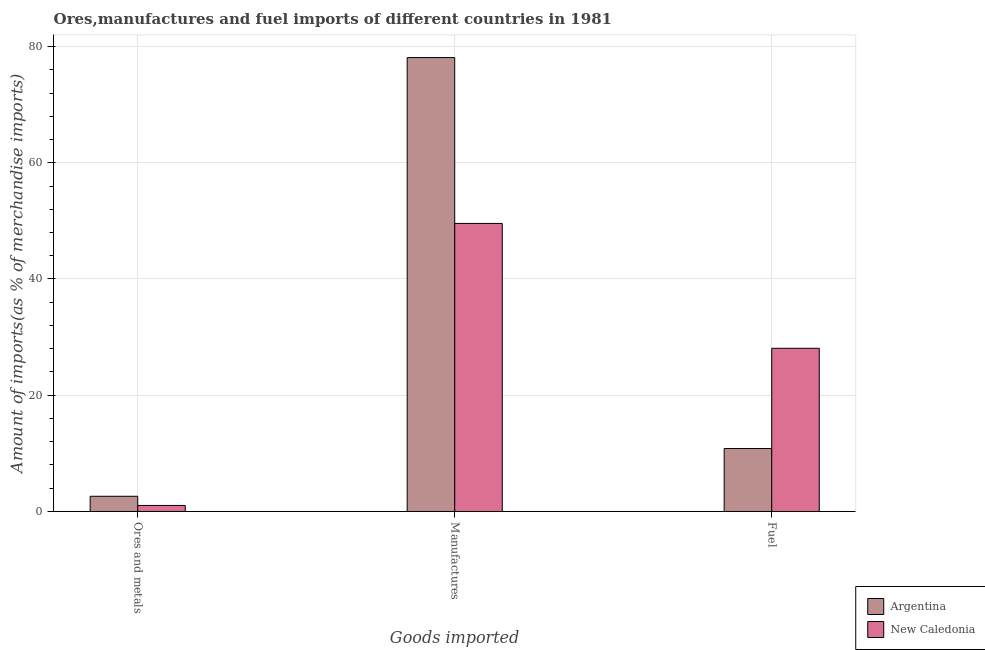How many groups of bars are there?
Offer a terse response. 3. Are the number of bars on each tick of the X-axis equal?
Ensure brevity in your answer.  Yes. What is the label of the 1st group of bars from the left?
Your response must be concise. Ores and metals. What is the percentage of fuel imports in Argentina?
Your answer should be compact. 10.83. Across all countries, what is the maximum percentage of manufactures imports?
Offer a terse response. 78.1. Across all countries, what is the minimum percentage of ores and metals imports?
Provide a short and direct response. 1.04. In which country was the percentage of ores and metals imports maximum?
Keep it short and to the point. Argentina. What is the total percentage of ores and metals imports in the graph?
Provide a short and direct response. 3.66. What is the difference between the percentage of fuel imports in Argentina and that in New Caledonia?
Offer a very short reply. -17.24. What is the difference between the percentage of fuel imports in Argentina and the percentage of ores and metals imports in New Caledonia?
Offer a terse response. 9.79. What is the average percentage of fuel imports per country?
Keep it short and to the point. 19.46. What is the difference between the percentage of ores and metals imports and percentage of fuel imports in New Caledonia?
Offer a very short reply. -27.04. What is the ratio of the percentage of manufactures imports in New Caledonia to that in Argentina?
Keep it short and to the point. 0.63. What is the difference between the highest and the second highest percentage of ores and metals imports?
Make the answer very short. 1.58. What is the difference between the highest and the lowest percentage of fuel imports?
Provide a succinct answer. 17.24. In how many countries, is the percentage of fuel imports greater than the average percentage of fuel imports taken over all countries?
Offer a very short reply. 1. Is the sum of the percentage of fuel imports in New Caledonia and Argentina greater than the maximum percentage of ores and metals imports across all countries?
Your answer should be compact. Yes. What does the 2nd bar from the left in Manufactures represents?
Offer a very short reply. New Caledonia. What does the 1st bar from the right in Ores and metals represents?
Keep it short and to the point. New Caledonia. How many bars are there?
Make the answer very short. 6. Are all the bars in the graph horizontal?
Offer a very short reply. No. Does the graph contain grids?
Your response must be concise. Yes. How are the legend labels stacked?
Offer a very short reply. Vertical. What is the title of the graph?
Give a very brief answer. Ores,manufactures and fuel imports of different countries in 1981. Does "Iran" appear as one of the legend labels in the graph?
Give a very brief answer. No. What is the label or title of the X-axis?
Ensure brevity in your answer.  Goods imported. What is the label or title of the Y-axis?
Provide a short and direct response. Amount of imports(as % of merchandise imports). What is the Amount of imports(as % of merchandise imports) in Argentina in Ores and metals?
Offer a terse response. 2.62. What is the Amount of imports(as % of merchandise imports) of New Caledonia in Ores and metals?
Ensure brevity in your answer.  1.04. What is the Amount of imports(as % of merchandise imports) in Argentina in Manufactures?
Make the answer very short. 78.1. What is the Amount of imports(as % of merchandise imports) of New Caledonia in Manufactures?
Provide a short and direct response. 49.56. What is the Amount of imports(as % of merchandise imports) in Argentina in Fuel?
Make the answer very short. 10.83. What is the Amount of imports(as % of merchandise imports) of New Caledonia in Fuel?
Make the answer very short. 28.08. Across all Goods imported, what is the maximum Amount of imports(as % of merchandise imports) of Argentina?
Your response must be concise. 78.1. Across all Goods imported, what is the maximum Amount of imports(as % of merchandise imports) in New Caledonia?
Your answer should be compact. 49.56. Across all Goods imported, what is the minimum Amount of imports(as % of merchandise imports) of Argentina?
Ensure brevity in your answer.  2.62. Across all Goods imported, what is the minimum Amount of imports(as % of merchandise imports) in New Caledonia?
Your response must be concise. 1.04. What is the total Amount of imports(as % of merchandise imports) of Argentina in the graph?
Offer a terse response. 91.55. What is the total Amount of imports(as % of merchandise imports) in New Caledonia in the graph?
Make the answer very short. 78.68. What is the difference between the Amount of imports(as % of merchandise imports) of Argentina in Ores and metals and that in Manufactures?
Offer a very short reply. -75.48. What is the difference between the Amount of imports(as % of merchandise imports) in New Caledonia in Ores and metals and that in Manufactures?
Your response must be concise. -48.52. What is the difference between the Amount of imports(as % of merchandise imports) in Argentina in Ores and metals and that in Fuel?
Keep it short and to the point. -8.22. What is the difference between the Amount of imports(as % of merchandise imports) in New Caledonia in Ores and metals and that in Fuel?
Keep it short and to the point. -27.04. What is the difference between the Amount of imports(as % of merchandise imports) of Argentina in Manufactures and that in Fuel?
Ensure brevity in your answer.  67.26. What is the difference between the Amount of imports(as % of merchandise imports) of New Caledonia in Manufactures and that in Fuel?
Make the answer very short. 21.49. What is the difference between the Amount of imports(as % of merchandise imports) in Argentina in Ores and metals and the Amount of imports(as % of merchandise imports) in New Caledonia in Manufactures?
Ensure brevity in your answer.  -46.95. What is the difference between the Amount of imports(as % of merchandise imports) in Argentina in Ores and metals and the Amount of imports(as % of merchandise imports) in New Caledonia in Fuel?
Provide a succinct answer. -25.46. What is the difference between the Amount of imports(as % of merchandise imports) in Argentina in Manufactures and the Amount of imports(as % of merchandise imports) in New Caledonia in Fuel?
Ensure brevity in your answer.  50.02. What is the average Amount of imports(as % of merchandise imports) of Argentina per Goods imported?
Provide a succinct answer. 30.52. What is the average Amount of imports(as % of merchandise imports) in New Caledonia per Goods imported?
Offer a terse response. 26.23. What is the difference between the Amount of imports(as % of merchandise imports) in Argentina and Amount of imports(as % of merchandise imports) in New Caledonia in Ores and metals?
Give a very brief answer. 1.58. What is the difference between the Amount of imports(as % of merchandise imports) in Argentina and Amount of imports(as % of merchandise imports) in New Caledonia in Manufactures?
Provide a succinct answer. 28.54. What is the difference between the Amount of imports(as % of merchandise imports) of Argentina and Amount of imports(as % of merchandise imports) of New Caledonia in Fuel?
Offer a very short reply. -17.24. What is the ratio of the Amount of imports(as % of merchandise imports) of Argentina in Ores and metals to that in Manufactures?
Keep it short and to the point. 0.03. What is the ratio of the Amount of imports(as % of merchandise imports) of New Caledonia in Ores and metals to that in Manufactures?
Offer a terse response. 0.02. What is the ratio of the Amount of imports(as % of merchandise imports) in Argentina in Ores and metals to that in Fuel?
Your answer should be very brief. 0.24. What is the ratio of the Amount of imports(as % of merchandise imports) of New Caledonia in Ores and metals to that in Fuel?
Keep it short and to the point. 0.04. What is the ratio of the Amount of imports(as % of merchandise imports) in Argentina in Manufactures to that in Fuel?
Make the answer very short. 7.21. What is the ratio of the Amount of imports(as % of merchandise imports) of New Caledonia in Manufactures to that in Fuel?
Give a very brief answer. 1.77. What is the difference between the highest and the second highest Amount of imports(as % of merchandise imports) in Argentina?
Provide a short and direct response. 67.26. What is the difference between the highest and the second highest Amount of imports(as % of merchandise imports) of New Caledonia?
Give a very brief answer. 21.49. What is the difference between the highest and the lowest Amount of imports(as % of merchandise imports) of Argentina?
Give a very brief answer. 75.48. What is the difference between the highest and the lowest Amount of imports(as % of merchandise imports) of New Caledonia?
Your answer should be compact. 48.52. 